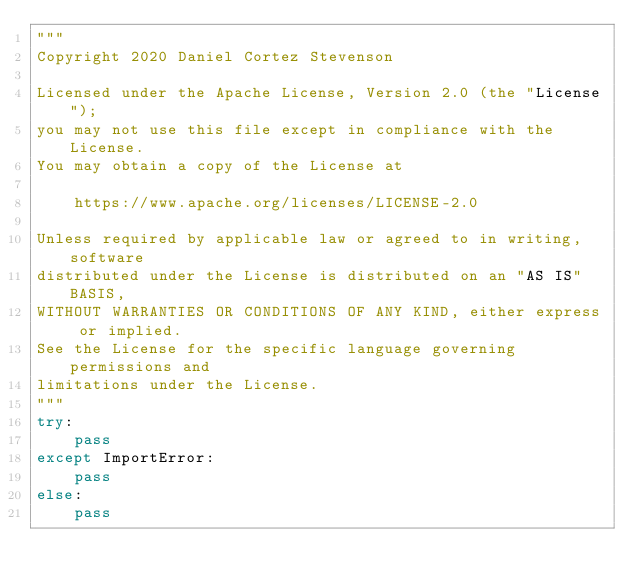<code> <loc_0><loc_0><loc_500><loc_500><_Python_>"""
Copyright 2020 Daniel Cortez Stevenson

Licensed under the Apache License, Version 2.0 (the "License");
you may not use this file except in compliance with the License.
You may obtain a copy of the License at

    https://www.apache.org/licenses/LICENSE-2.0

Unless required by applicable law or agreed to in writing, software
distributed under the License is distributed on an "AS IS" BASIS,
WITHOUT WARRANTIES OR CONDITIONS OF ANY KIND, either express or implied.
See the License for the specific language governing permissions and
limitations under the License.
"""
try:
    pass
except ImportError:
    pass
else:
    pass
</code> 